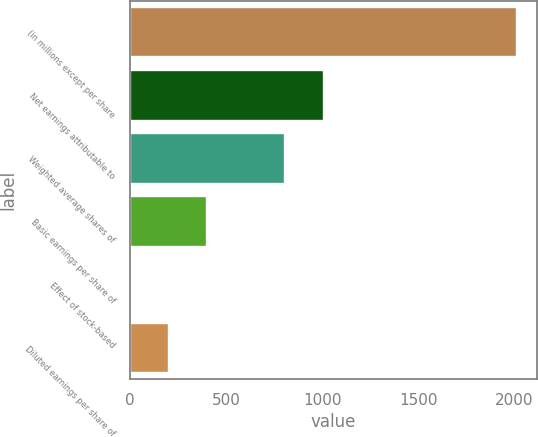<chart> <loc_0><loc_0><loc_500><loc_500><bar_chart><fcel>(in millions except per share<fcel>Net earnings attributable to<fcel>Weighted average shares of<fcel>Basic earnings per share of<fcel>Effect of stock-based<fcel>Diluted earnings per share of<nl><fcel>2015<fcel>1008.13<fcel>806.75<fcel>403.99<fcel>1.23<fcel>202.61<nl></chart> 